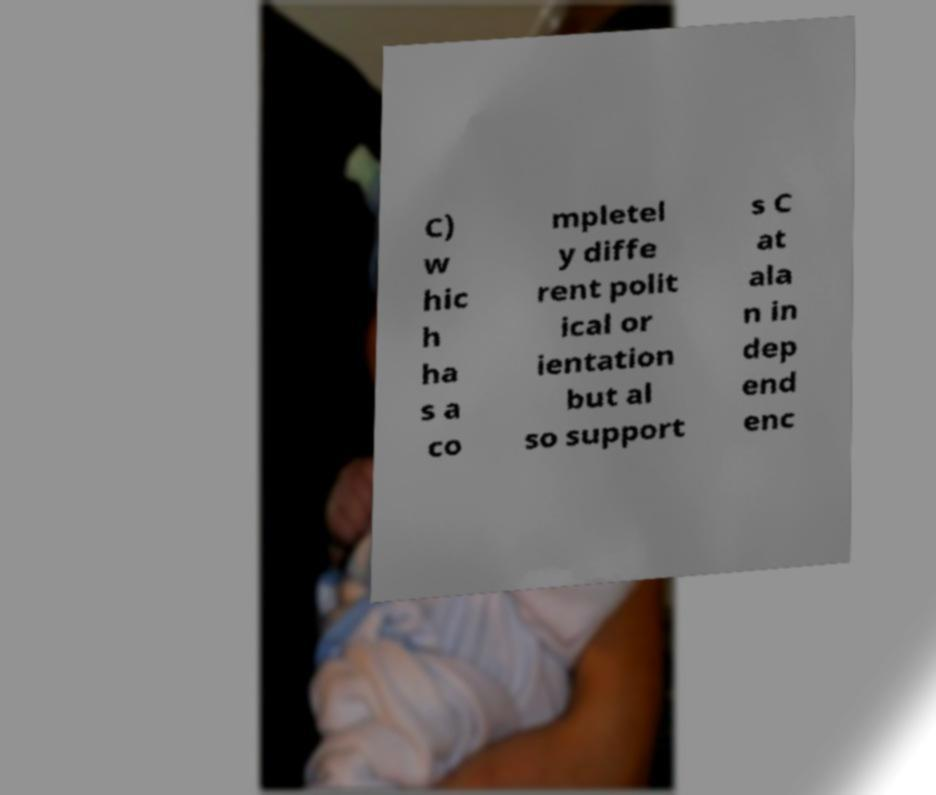Could you extract and type out the text from this image? C) w hic h ha s a co mpletel y diffe rent polit ical or ientation but al so support s C at ala n in dep end enc 